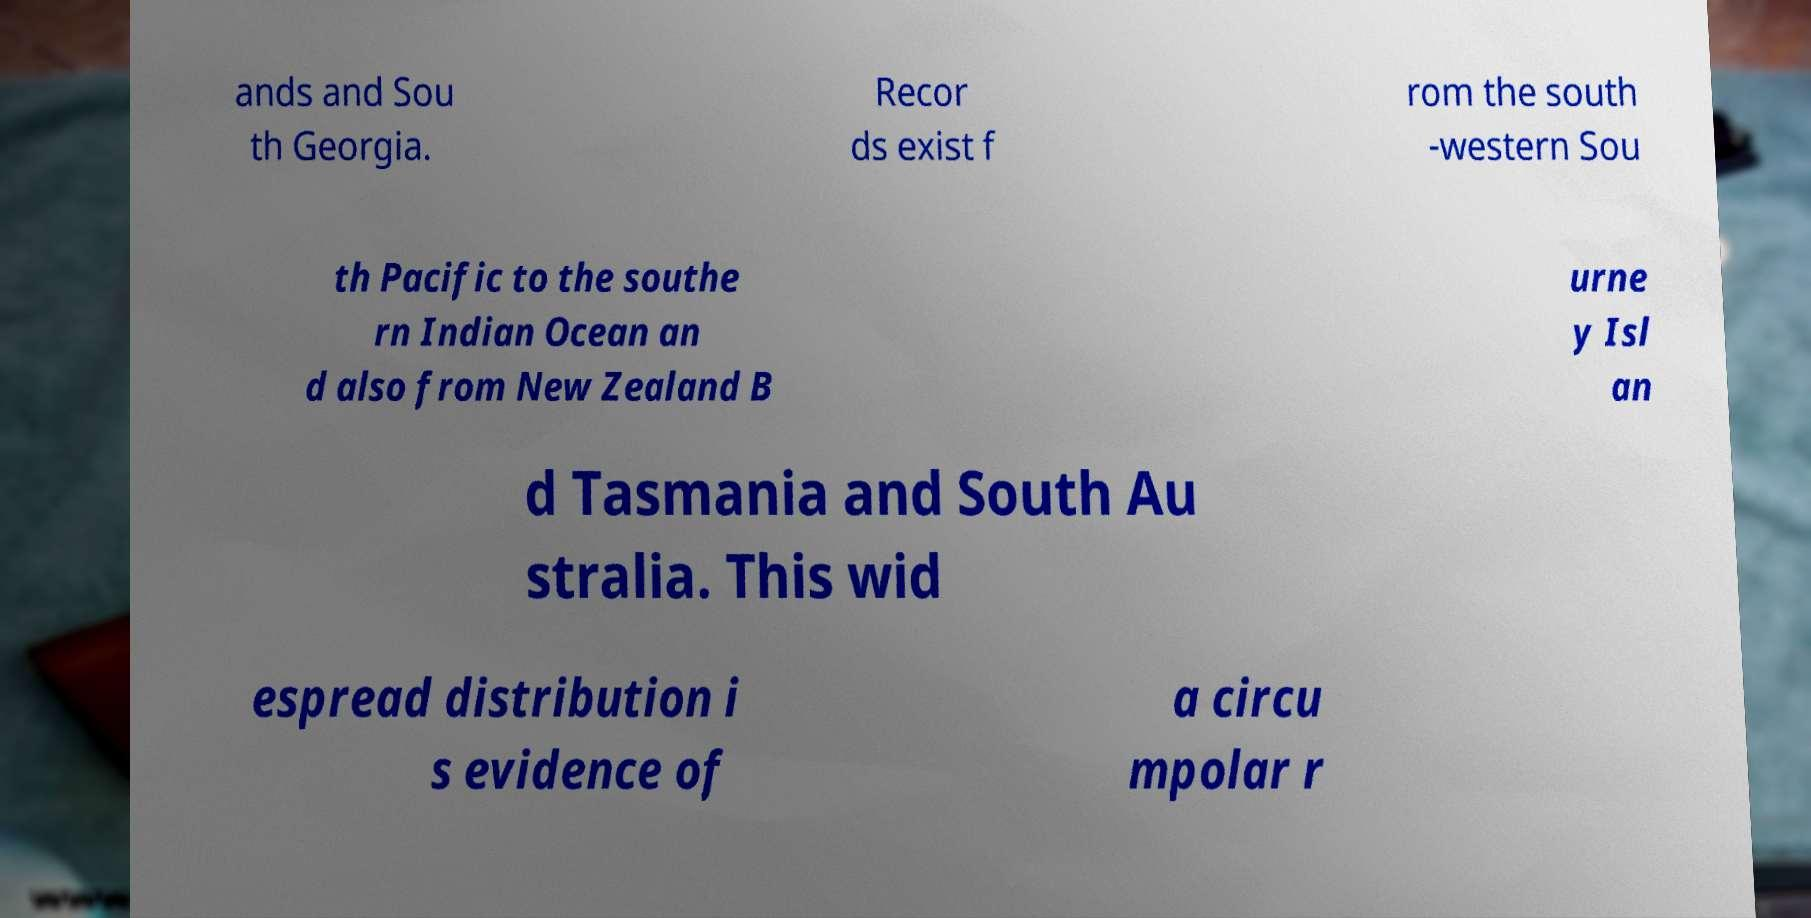Please identify and transcribe the text found in this image. ands and Sou th Georgia. Recor ds exist f rom the south -western Sou th Pacific to the southe rn Indian Ocean an d also from New Zealand B urne y Isl an d Tasmania and South Au stralia. This wid espread distribution i s evidence of a circu mpolar r 